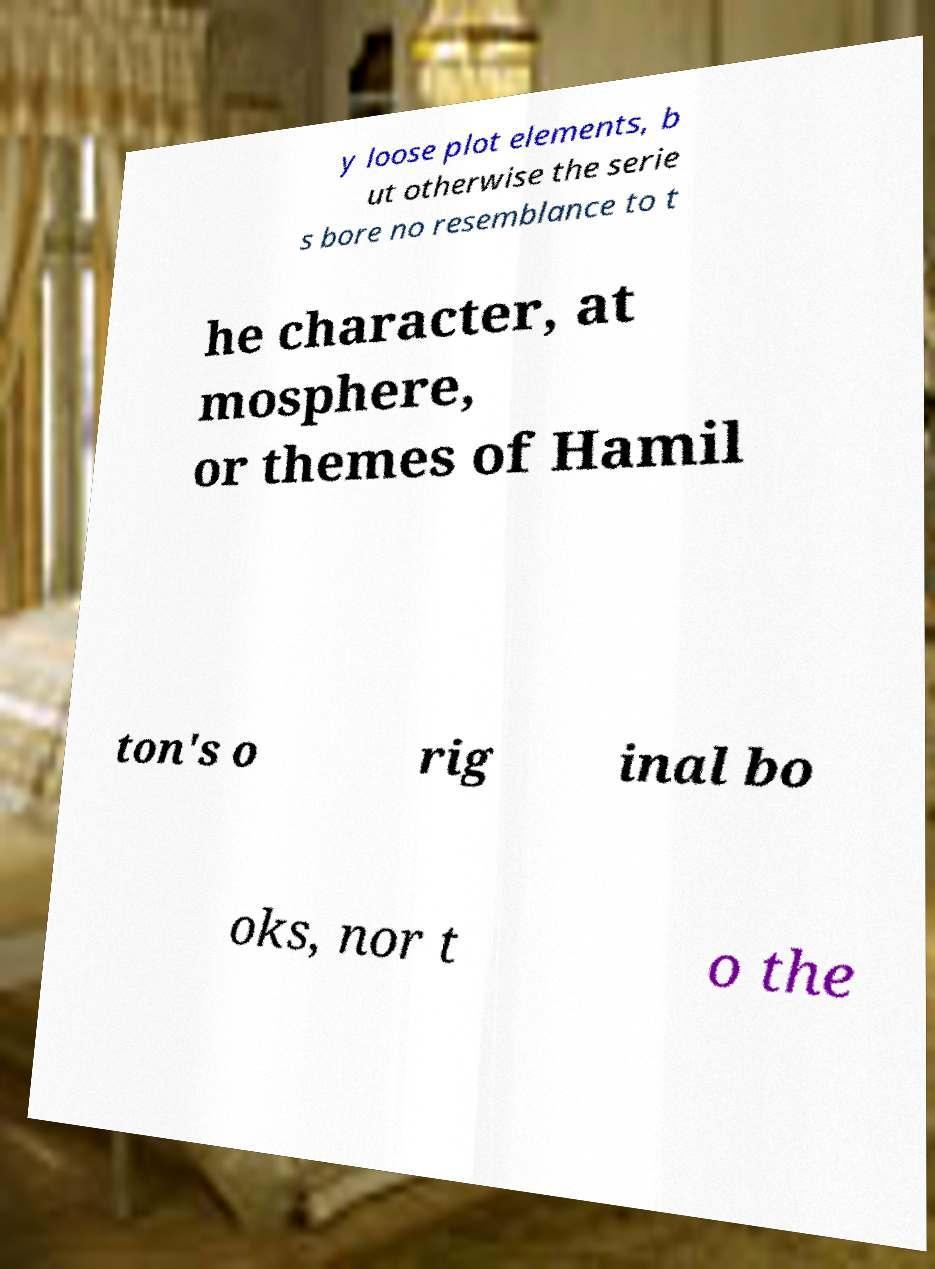Can you accurately transcribe the text from the provided image for me? y loose plot elements, b ut otherwise the serie s bore no resemblance to t he character, at mosphere, or themes of Hamil ton's o rig inal bo oks, nor t o the 